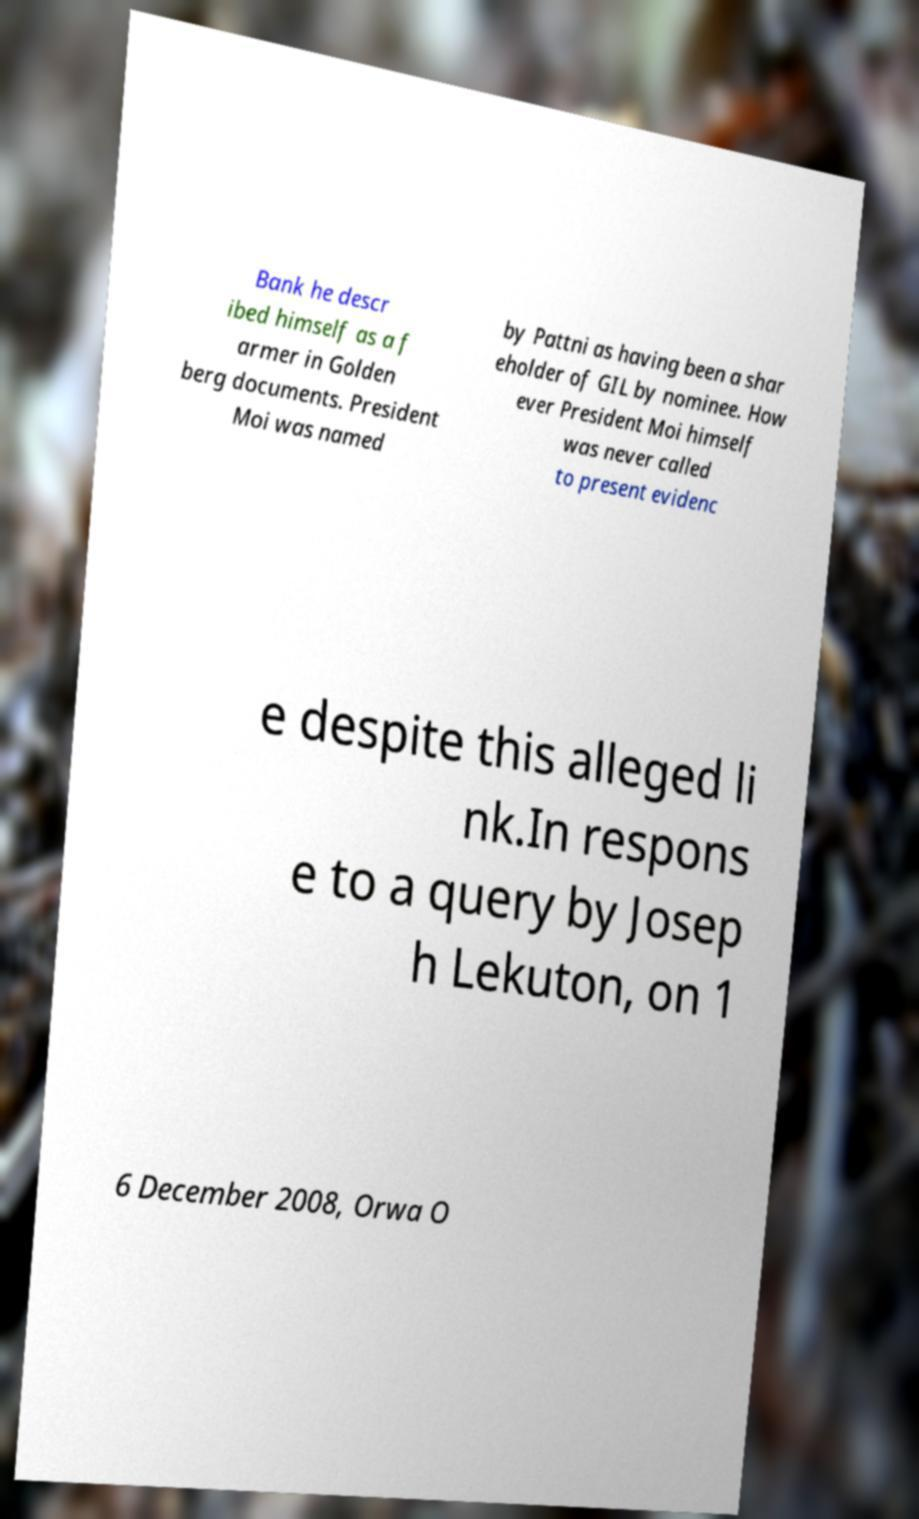Please read and relay the text visible in this image. What does it say? Bank he descr ibed himself as a f armer in Golden berg documents. President Moi was named by Pattni as having been a shar eholder of GIL by nominee. How ever President Moi himself was never called to present evidenc e despite this alleged li nk.In respons e to a query by Josep h Lekuton, on 1 6 December 2008, Orwa O 